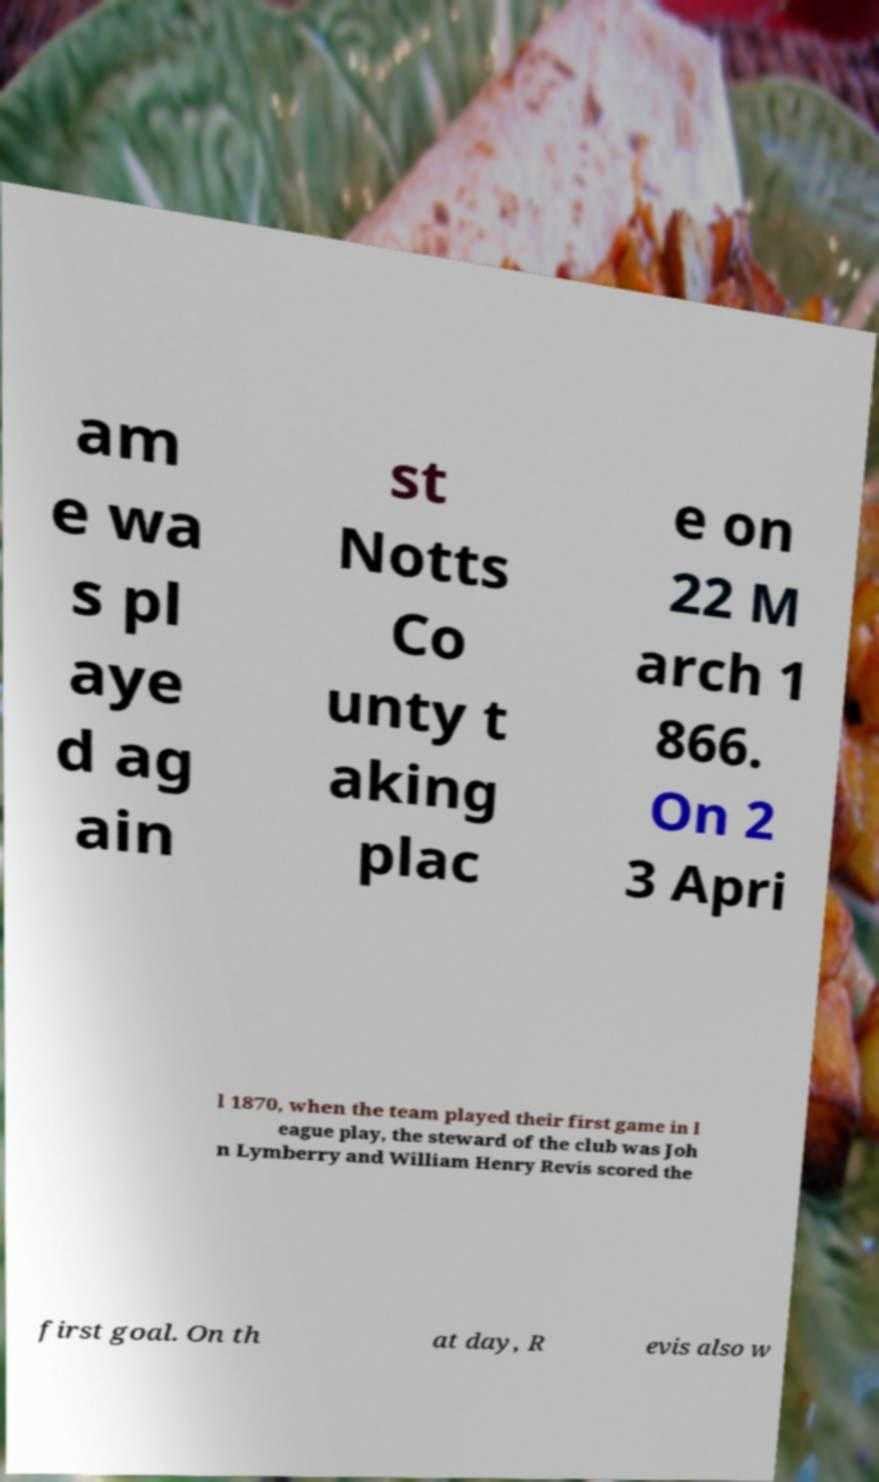Can you accurately transcribe the text from the provided image for me? am e wa s pl aye d ag ain st Notts Co unty t aking plac e on 22 M arch 1 866. On 2 3 Apri l 1870, when the team played their first game in l eague play, the steward of the club was Joh n Lymberry and William Henry Revis scored the first goal. On th at day, R evis also w 